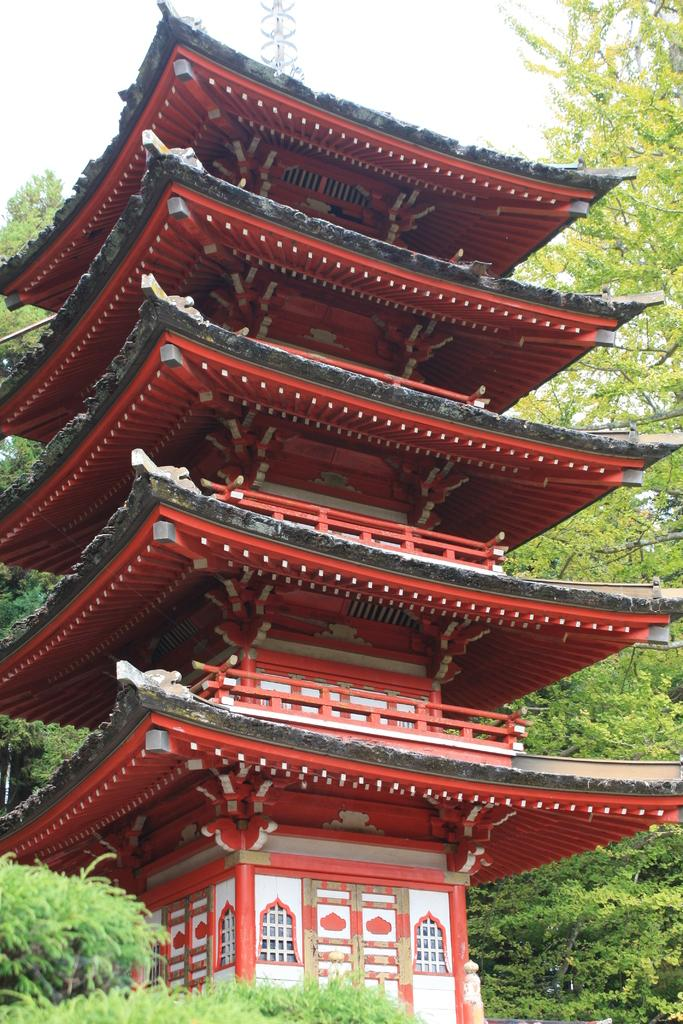What type of structure is present in the image? There is a building in the image. What feature can be seen on the building? The building has windows. What type of vegetation is visible in the image? There are trees in the image. What is visible in the background of the image? The sky is visible in the image. What type of voice can be heard coming from the building in the image? There is no indication of any sound or voice in the image, as it only shows a building with windows, trees, and the sky. 